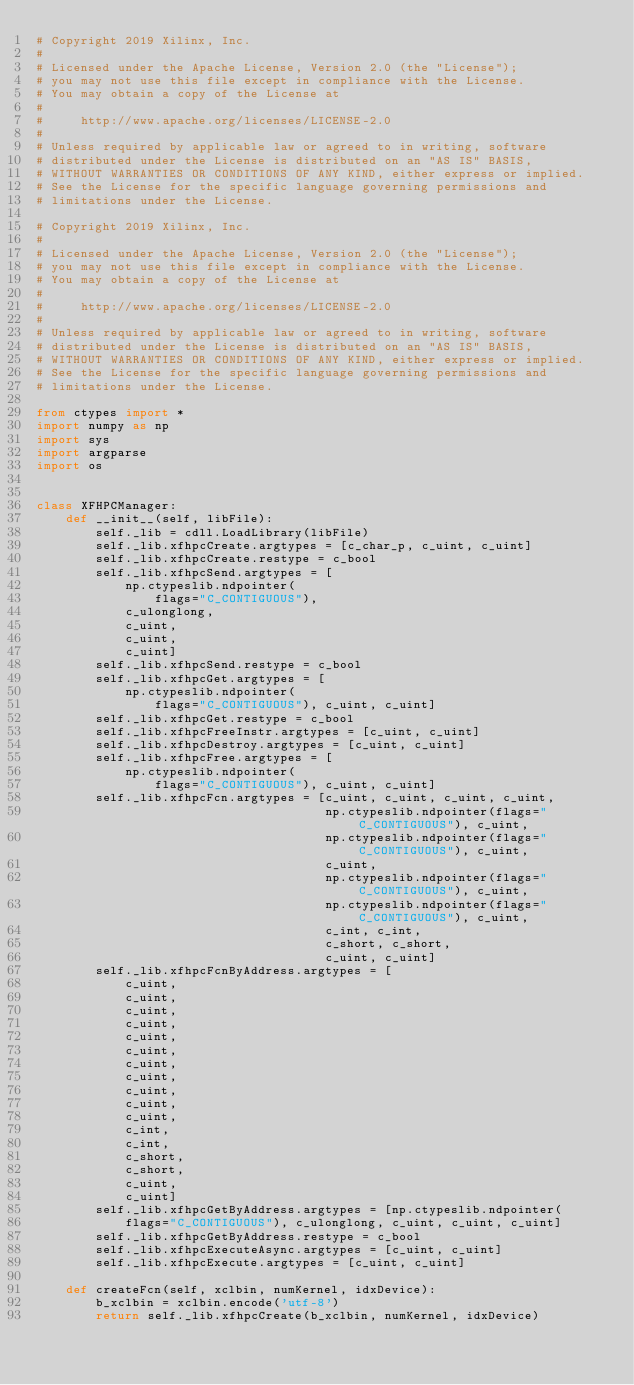<code> <loc_0><loc_0><loc_500><loc_500><_Python_># Copyright 2019 Xilinx, Inc.
#
# Licensed under the Apache License, Version 2.0 (the "License");
# you may not use this file except in compliance with the License.
# You may obtain a copy of the License at
#
#     http://www.apache.org/licenses/LICENSE-2.0
#
# Unless required by applicable law or agreed to in writing, software
# distributed under the License is distributed on an "AS IS" BASIS,
# WITHOUT WARRANTIES OR CONDITIONS OF ANY KIND, either express or implied.
# See the License for the specific language governing permissions and
# limitations under the License.

# Copyright 2019 Xilinx, Inc.
#
# Licensed under the Apache License, Version 2.0 (the "License");
# you may not use this file except in compliance with the License.
# You may obtain a copy of the License at
#
#     http://www.apache.org/licenses/LICENSE-2.0
#
# Unless required by applicable law or agreed to in writing, software
# distributed under the License is distributed on an "AS IS" BASIS,
# WITHOUT WARRANTIES OR CONDITIONS OF ANY KIND, either express or implied.
# See the License for the specific language governing permissions and
# limitations under the License.

from ctypes import *
import numpy as np
import sys
import argparse
import os


class XFHPCManager:
    def __init__(self, libFile):
        self._lib = cdll.LoadLibrary(libFile)
        self._lib.xfhpcCreate.argtypes = [c_char_p, c_uint, c_uint]
        self._lib.xfhpcCreate.restype = c_bool
        self._lib.xfhpcSend.argtypes = [
            np.ctypeslib.ndpointer(
                flags="C_CONTIGUOUS"),
            c_ulonglong,
            c_uint,
            c_uint,
            c_uint]
        self._lib.xfhpcSend.restype = c_bool
        self._lib.xfhpcGet.argtypes = [
            np.ctypeslib.ndpointer(
                flags="C_CONTIGUOUS"), c_uint, c_uint]
        self._lib.xfhpcGet.restype = c_bool
        self._lib.xfhpcFreeInstr.argtypes = [c_uint, c_uint]
        self._lib.xfhpcDestroy.argtypes = [c_uint, c_uint]
        self._lib.xfhpcFree.argtypes = [
            np.ctypeslib.ndpointer(
                flags="C_CONTIGUOUS"), c_uint, c_uint]
        self._lib.xfhpcFcn.argtypes = [c_uint, c_uint, c_uint, c_uint,
                                       np.ctypeslib.ndpointer(flags="C_CONTIGUOUS"), c_uint,
                                       np.ctypeslib.ndpointer(flags="C_CONTIGUOUS"), c_uint,
                                       c_uint,
                                       np.ctypeslib.ndpointer(flags="C_CONTIGUOUS"), c_uint,
                                       np.ctypeslib.ndpointer(flags="C_CONTIGUOUS"), c_uint,
                                       c_int, c_int,
                                       c_short, c_short,
                                       c_uint, c_uint]
        self._lib.xfhpcFcnByAddress.argtypes = [
            c_uint,
            c_uint,
            c_uint,
            c_uint,
            c_uint,
            c_uint,
            c_uint,
            c_uint,
            c_uint,
            c_uint,
            c_uint,
            c_int,
            c_int,
            c_short,
            c_short,
            c_uint,
            c_uint]
        self._lib.xfhpcGetByAddress.argtypes = [np.ctypeslib.ndpointer(
            flags="C_CONTIGUOUS"), c_ulonglong, c_uint, c_uint, c_uint]
        self._lib.xfhpcGetByAddress.restype = c_bool
        self._lib.xfhpcExecuteAsync.argtypes = [c_uint, c_uint]
        self._lib.xfhpcExecute.argtypes = [c_uint, c_uint]

    def createFcn(self, xclbin, numKernel, idxDevice):
        b_xclbin = xclbin.encode('utf-8')
        return self._lib.xfhpcCreate(b_xclbin, numKernel, idxDevice)
</code> 